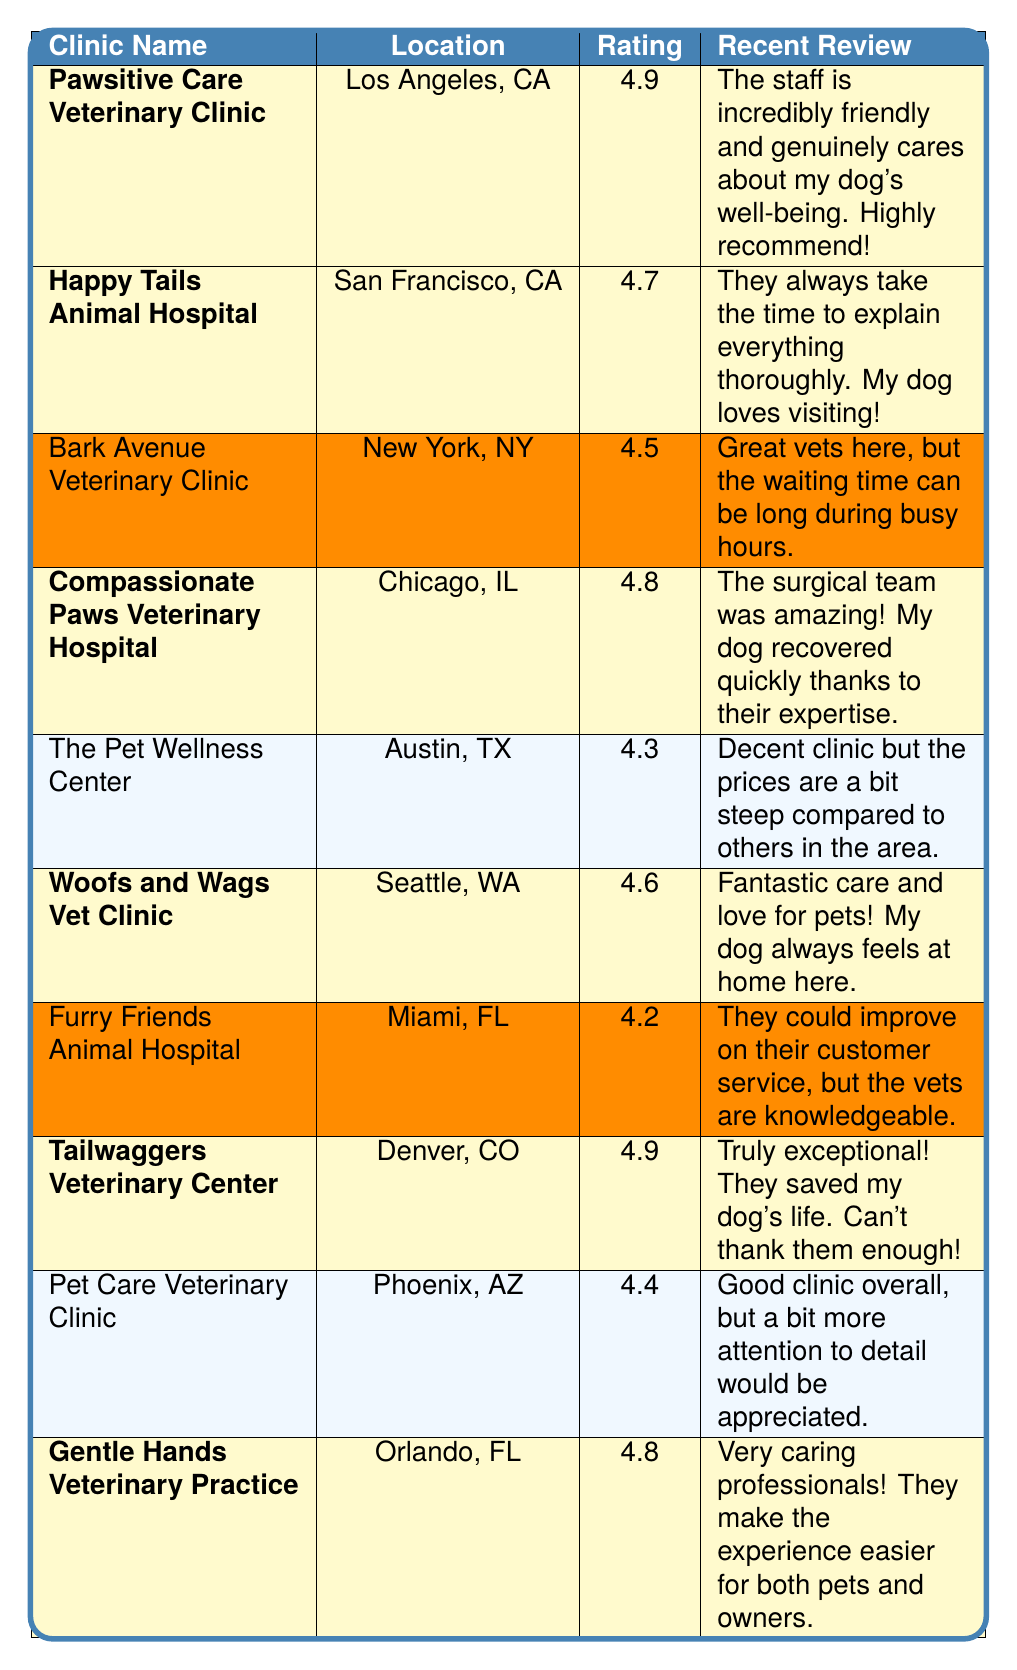What is the highest rating among the clinics? The ratings of the clinics listed are 4.9, 4.7, 4.5, 4.8, 4.3, 4.6, 4.2, 4.9, 4.4, and 4.8. The maximum value is 4.9.
Answer: 4.9 How many reviews does Woofs and Wags Vet Clinic have? The number of reviews for Woofs and Wags Vet Clinic is provided in the table as 150.
Answer: 150 Which clinic has the most reviews? Bark Avenue Veterinary Clinic has the most reviews with a total of 200.
Answer: Bark Avenue Veterinary Clinic Are all highlighted clinics rated above 4.5? The highlighted clinics have ratings of 4.9, 4.7, 4.8, 4.6, 4.9, and 4.8. All of these ratings are above 4.5, confirming the statement is true.
Answer: Yes What is the average rating of the highlighted clinics? The ratings of the highlighted clinics are 4.9, 4.7, 4.8, 4.6, 4.9, and 4.8. Adding them gives 29.7, and since there are 6 clinics, the average rating is 29.7 / 6 = 4.95.
Answer: 4.95 Is there a clinic located in Orlando, FL, and what is its rating? Yes, Gentle Hands Veterinary Practice is located in Orlando, FL, and its rating is 4.8.
Answer: Yes, 4.8 How many clinics have a rating of 4.8 or higher? The clinics with ratings of 4.8 or higher are Pawsitive Care, Compassionate Paws, Tailwaggers, and Gentle Hands, totaling 4 clinics.
Answer: 4 Which clinic has the lowest rating among the highlighted clinics? The highlighted clinics have ratings of 4.9, 4.7, 4.8, 4.6, 4.9, and 4.8. The lowest among these is 4.6 from Woofs and Wags Vet Clinic.
Answer: 4.6 What is the ratio of the number of reviews for Tailwaggers Veterinary Center to Furry Friends Animal Hospital? Tailwaggers has 110 reviews and Furry Friends has 60 reviews. The ratio is 110:60, which simplifies to 11:6.
Answer: 11:6 Which clinic has the most positive recent review? The recent reviews for the highlighted clinics indicate exceptional care, and the review for Tailwaggers mentions saving a dog's life, implying it stands out the most.
Answer: Tailwaggers Veterinary Center 